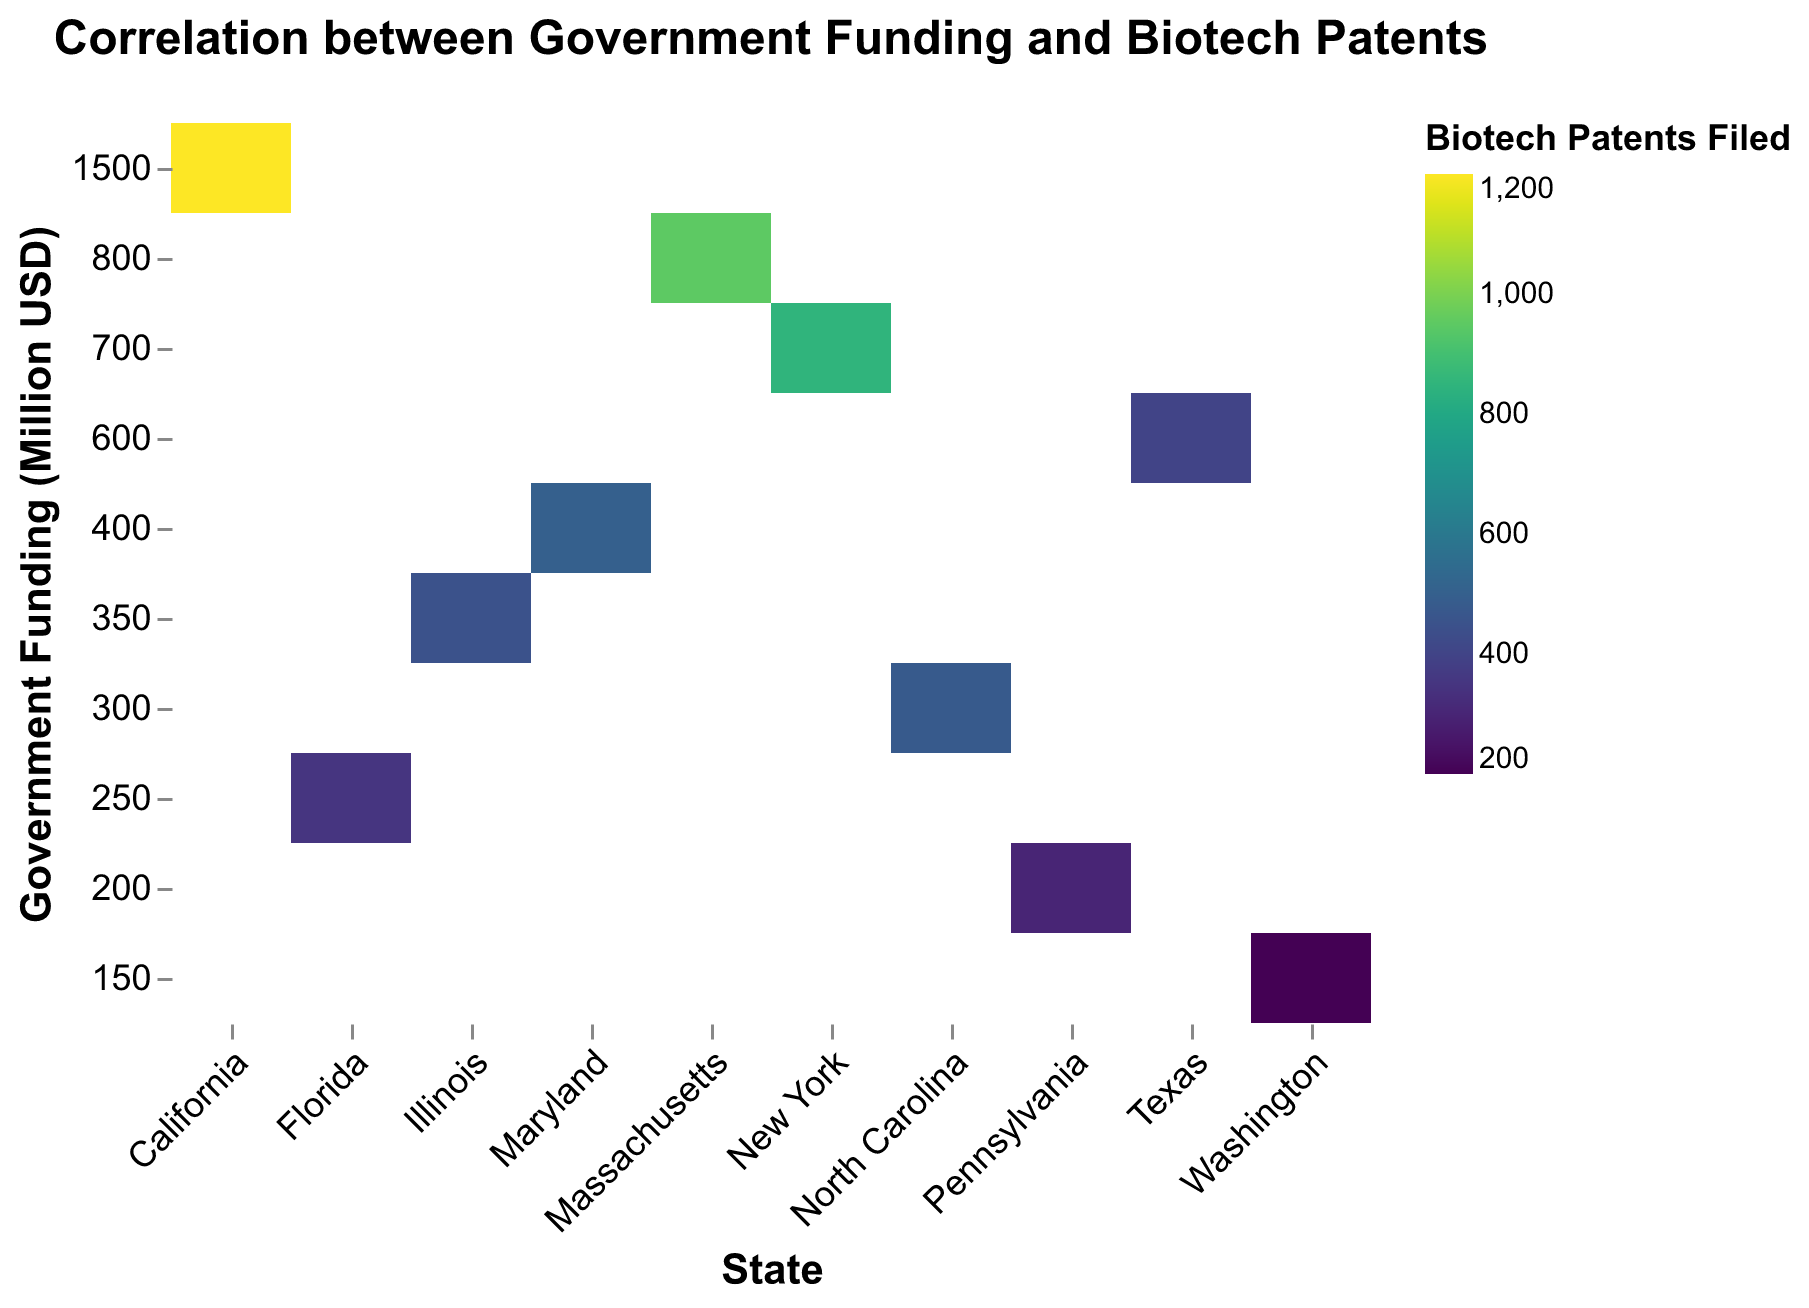What's the title of the heatmap? The title of the heatmap is displayed prominently at the top. It is labeled "Correlation between Government Funding and Biotech Patents," indicating the relationship being analyzed.
Answer: Correlation between Government Funding and Biotech Patents Which state received the highest amount of government funding? By looking at the y-axis sorted in descending order, we can see that the highest value at the top is linked to California.
Answer: California How many categories of government funding are displayed on the y-axis? The y-axis represents "Government Funding (Million USD)" in ordinal data with distinct bars. Counting the number of labels on the y-axis gives us the answer.
Answer: 10 Which state has the darkest color on the heatmap, indicating the highest number of biotech patents filed? The color scale suggests that the darkest color represents the highest number of patents. California's rectangle appears darkest.
Answer: California By how much does the number of biotech patents filed in California exceed that in Texas? California filed 1200 patents, while Texas filed 400 patents. The difference between these values is calculated by subtracting the smaller from the larger. 1200 - 400 = 800.
Answer: 800 What is the relationship between government funding and biotech patents filed in Massachusetts? Massachusetts has government funding of 800 million USD and filed 950 biotech patents. This suggests a positive relationship between government funding and patent filings in this state.
Answer: Positive Which states received less than 300 million USD in government funding? Checking the states corresponding to funding less than 300 million USD on the y-axis, we find Florida, Pennsylvania, and Washington.
Answer: Florida, Pennsylvania, Washington Which states filed more than 400 but less than 500 biotech patents? The rectangles that match these criteria are those for Maryland (500 patents just above 500), North Carolina (480 patents), and Illinois (450 patents).
Answer: Maryland, North Carolina, Illinois Is there a general trend between government funding and the number of biotech patents filed across states? Observing that states with higher funding generally have darker colors indicating more patents filed (e.g., California, Massachusetts) suggests a positive correlation between government funding and biotech patents filed.
Answer: Yes Which state has both the lowest government funding and the lowest number of biotech patents filed? By looking at the state corresponding to the lowest y-axis funding (150 million USD) and also having the lightest color (200 patents), it matches Washington.
Answer: Washington 